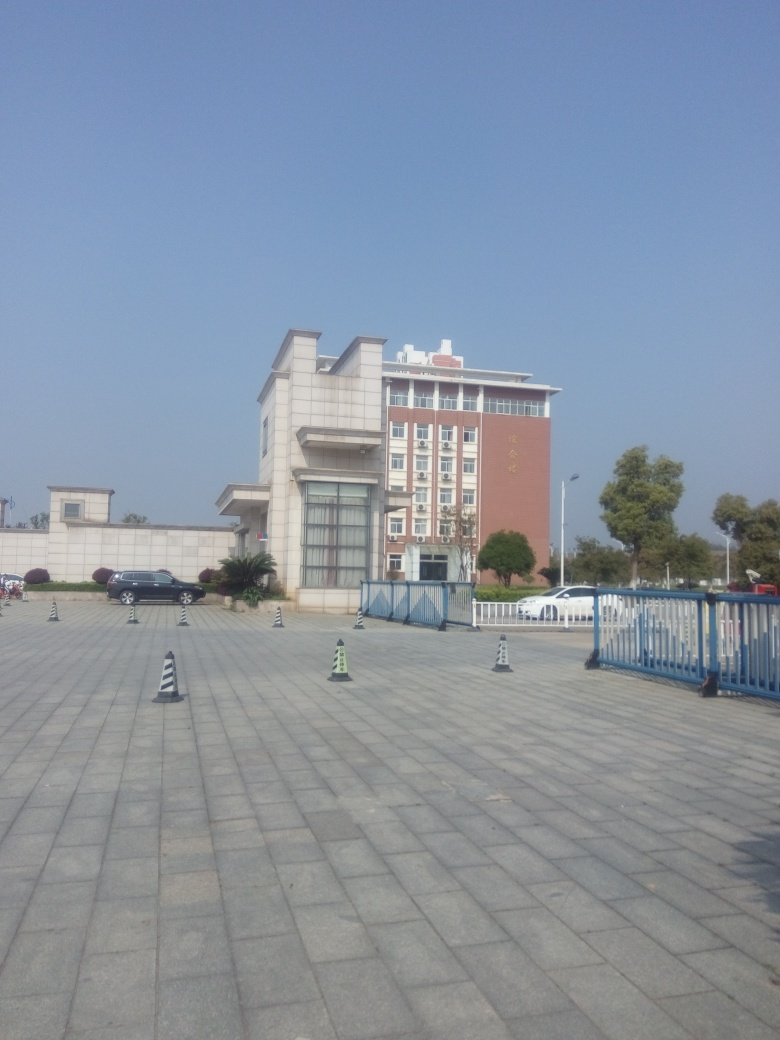Is the area around the building busy or deserted? The area around the building seems deserted at the time the photo was taken. There is a notable lack of pedestrian activity on the expansive pavement, and the parked cars are few, suggesting low activity levels or it being a non-peak hour. 